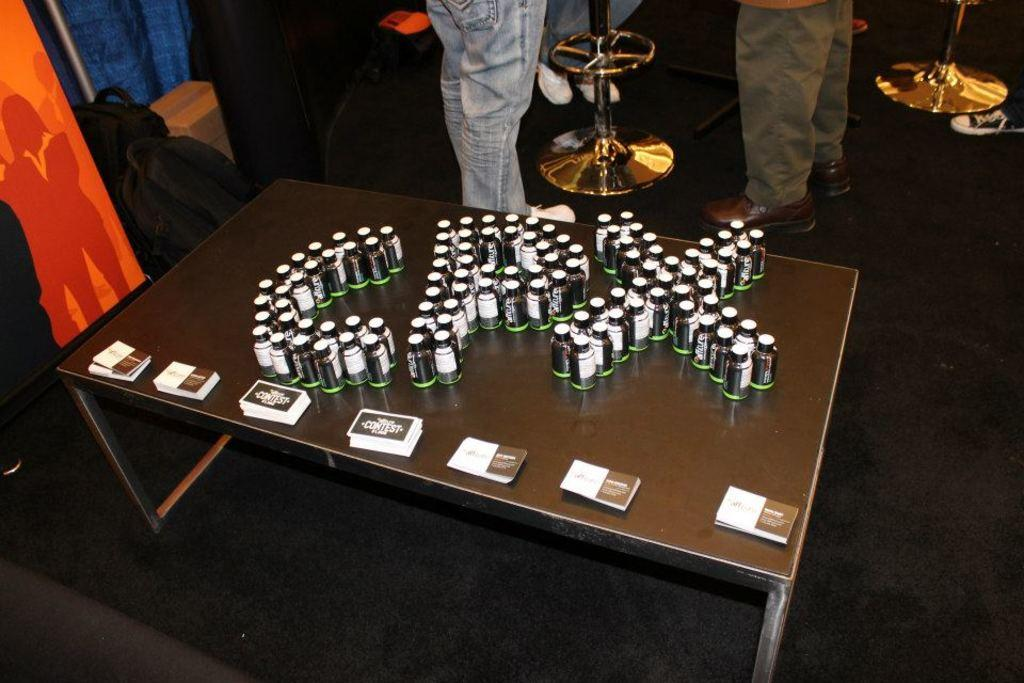What objects are on the table in the image? There are bottles and cards on the table in the image. What else can be seen on the floor near the table? There are persons' legs visible on the floor, as well as bags on the floor to the left of the table. What is located to the left of the table? There is a board to the left of the table. What type of fang can be seen in the image? There is no fang present in the image. How many sheep are visible in the image? There are no sheep present in the image. 